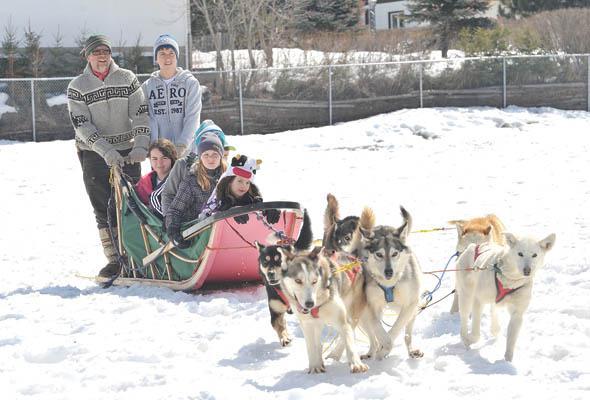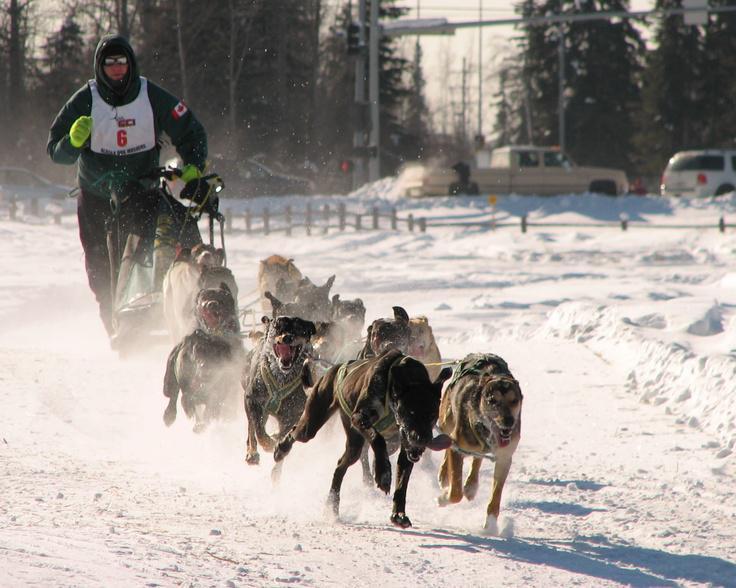The first image is the image on the left, the second image is the image on the right. Evaluate the accuracy of this statement regarding the images: "The person driving the sled in the image on the right is wearing a white numbered vest.". Is it true? Answer yes or no. Yes. The first image is the image on the left, the second image is the image on the right. Assess this claim about the two images: "At least one man is riding a sled wearing a white vest that is numbered.". Correct or not? Answer yes or no. Yes. 